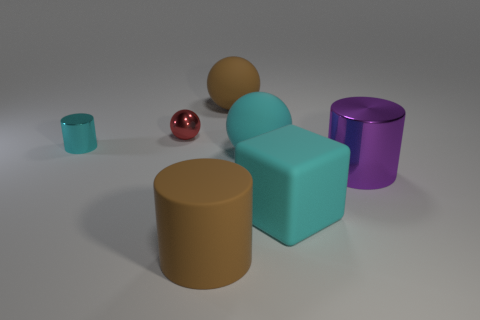Subtract all cyan metallic cylinders. How many cylinders are left? 2 Add 1 tiny things. How many objects exist? 8 Subtract all cyan balls. How many balls are left? 2 Subtract all cubes. How many objects are left? 6 Add 6 big brown matte cylinders. How many big brown matte cylinders are left? 7 Add 3 small red shiny cubes. How many small red shiny cubes exist? 3 Subtract 1 brown cylinders. How many objects are left? 6 Subtract 2 balls. How many balls are left? 1 Subtract all yellow balls. Subtract all green cylinders. How many balls are left? 3 Subtract all green spheres. How many brown cylinders are left? 1 